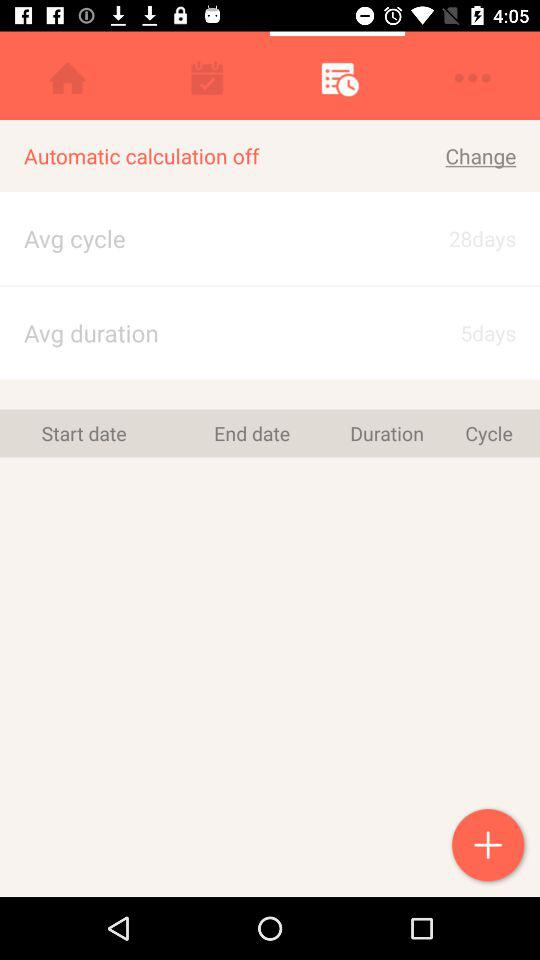What is the average cycle duration? It is 28 days. 